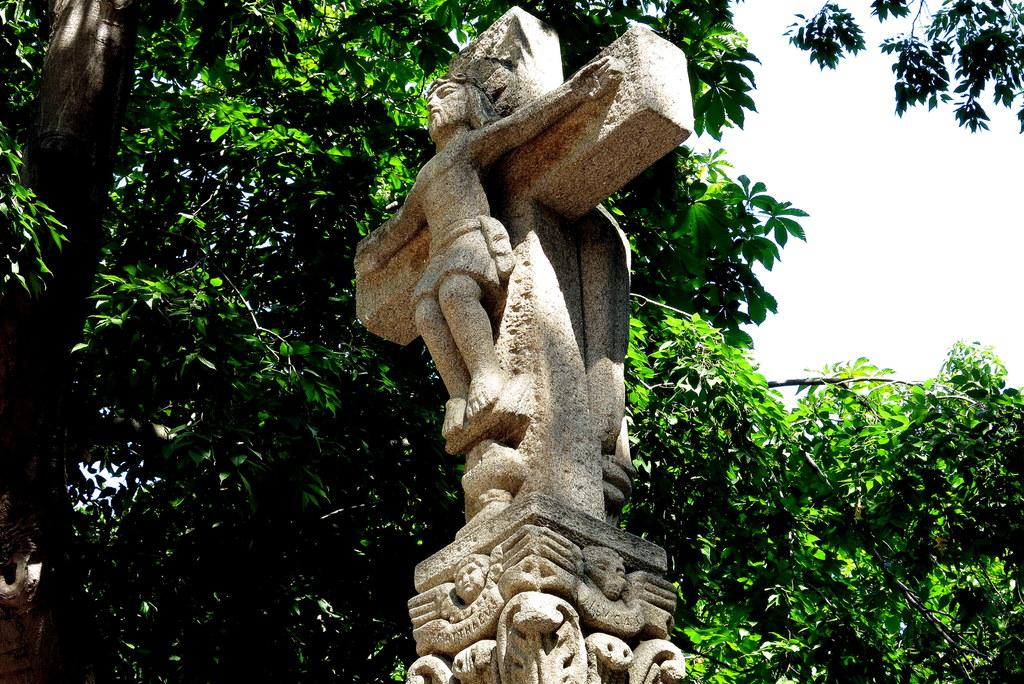What is the main subject of the image? There is a sculpture in the image. What can be seen behind the sculpture? There are trees behind the sculpture. What part of the sky is visible in the image? The sky is visible in the top right of the image. What songs is the actor singing in the image? There is no actor or songs present in the image; it features a sculpture and trees. What type of spade is being used to dig near the sculpture? There is no spade or digging activity present in the image. 